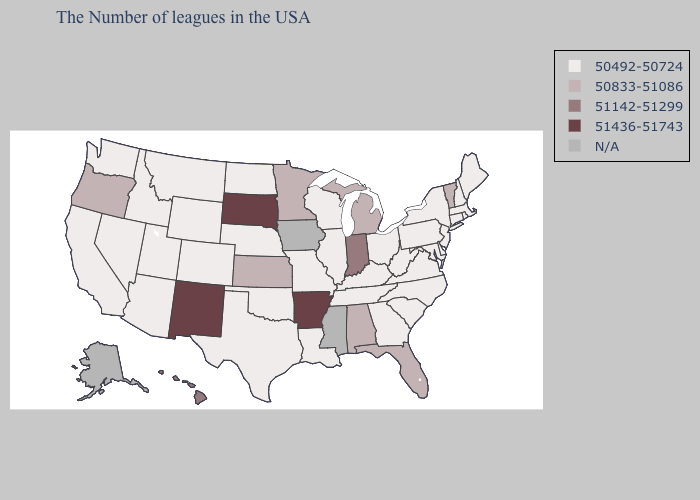Which states have the lowest value in the West?
Answer briefly. Wyoming, Colorado, Utah, Montana, Arizona, Idaho, Nevada, California, Washington. Does West Virginia have the lowest value in the USA?
Be succinct. Yes. Does the first symbol in the legend represent the smallest category?
Give a very brief answer. Yes. Among the states that border Oregon , which have the lowest value?
Be succinct. Idaho, Nevada, California, Washington. Does Arkansas have the highest value in the South?
Quick response, please. Yes. Name the states that have a value in the range 51142-51299?
Quick response, please. Indiana, Hawaii. Name the states that have a value in the range 51142-51299?
Quick response, please. Indiana, Hawaii. Does New Mexico have the highest value in the USA?
Answer briefly. Yes. Does Hawaii have the highest value in the West?
Keep it brief. No. What is the highest value in the South ?
Be succinct. 51436-51743. What is the highest value in states that border Georgia?
Write a very short answer. 50833-51086. What is the value of Minnesota?
Give a very brief answer. 50833-51086. Does Maine have the lowest value in the USA?
Keep it brief. Yes. What is the value of Florida?
Give a very brief answer. 50833-51086. Among the states that border Pennsylvania , which have the highest value?
Quick response, please. New York, New Jersey, Delaware, Maryland, West Virginia, Ohio. 